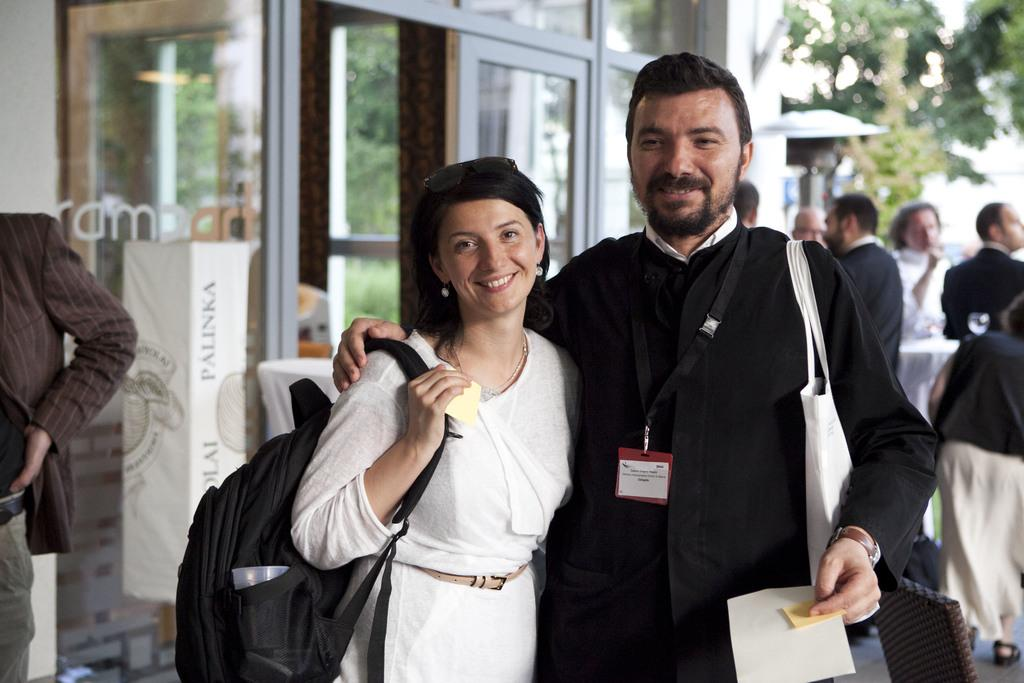What is the gender of the person in the image? There is a lady in the image. What is the lady wearing on her back? The lady is wearing a backpack. What is the guy in the image doing? The guy is holding something. How many other people are present in the image? There are other people in the image. What type of vegetation can be seen in the image? There is a tree in the image. What architectural feature is visible in the image? There is a glass door in the image. What is the lady's opinion on the comfort of the week in the image? There is no information about the lady's opinion or the comfort of the week in the image. 